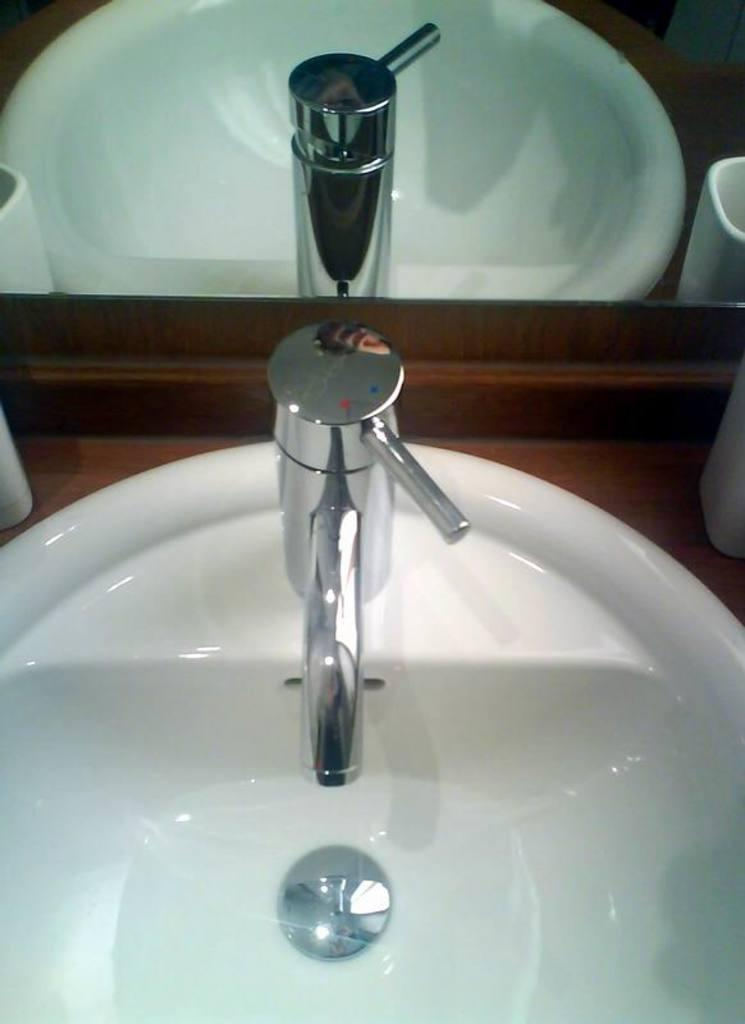What is the main object in the center of the image? There is a sink in the center of the image. What is attached to the sink? There is a tap on the sink. What is located near the sink? There is a mug near the sink. What can be seen in the background of the image? There is a mirror in the background of the image. What is reflected in the mirror? The reflection of the sink, tap, mug, and tissue paper is visible in the mirror. What type of trail can be seen in the image? There is no trail present in the image; it features a sink, tap, mug, and mirror. What kind of rifle is visible in the image? There is no rifle present in the image. 